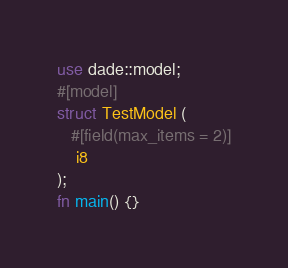Convert code to text. <code><loc_0><loc_0><loc_500><loc_500><_Rust_>use dade::model;
#[model]
struct TestModel (
   #[field(max_items = 2)]
    i8
);
fn main() {}
</code> 